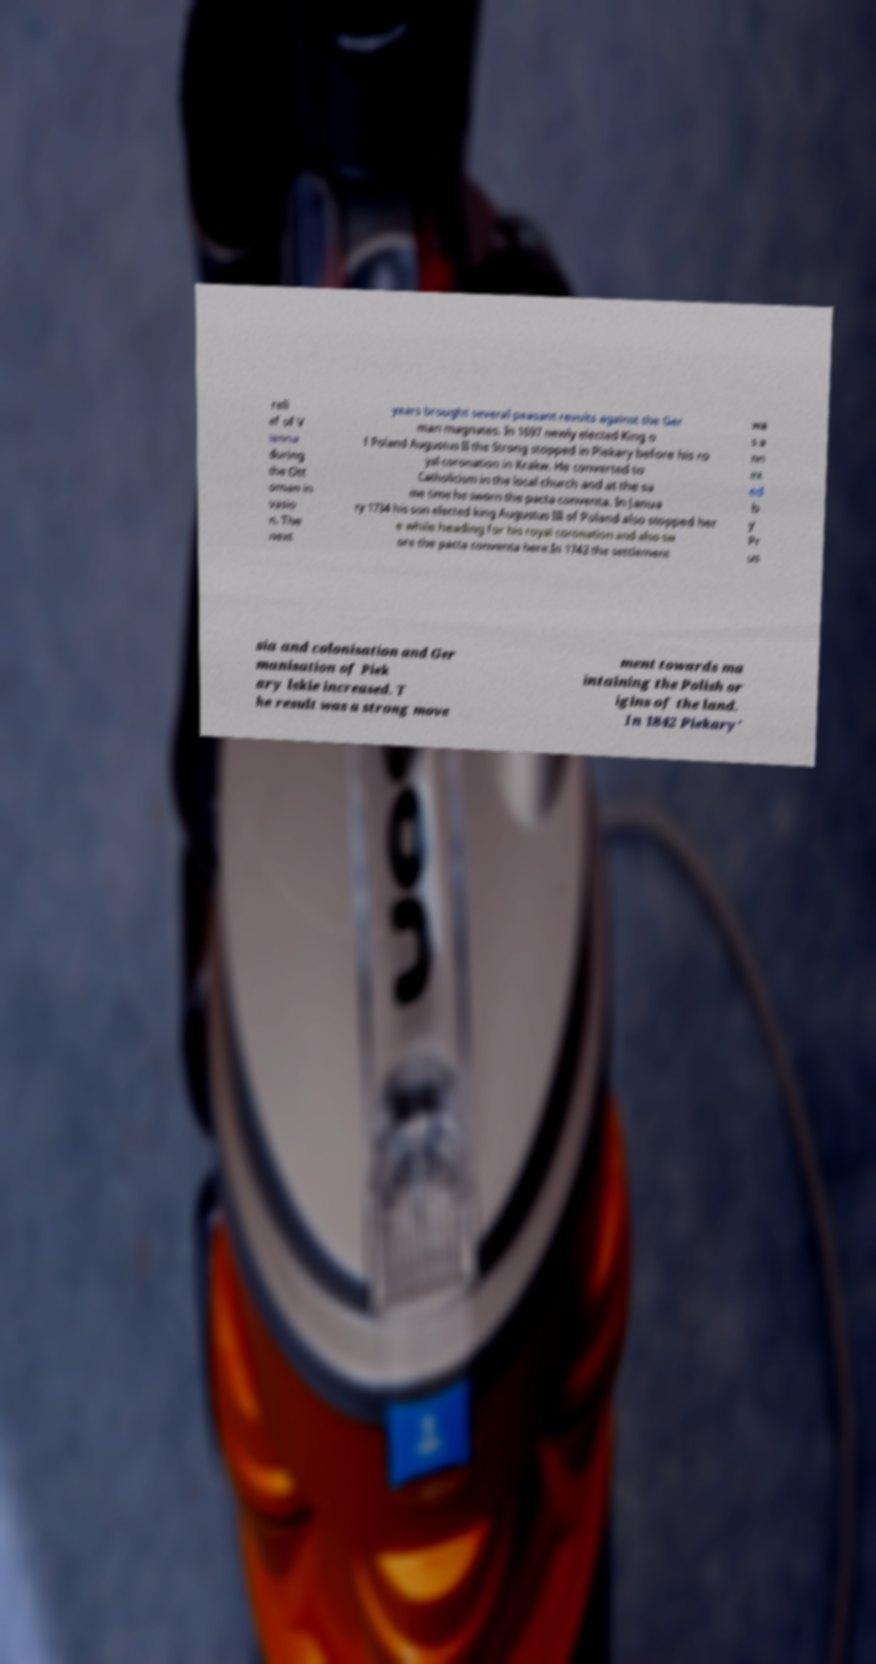Please read and relay the text visible in this image. What does it say? reli ef of V ienna during the Ott oman in vasio n. The next years brought several peasant revolts against the Ger man magnates. In 1697 newly elected King o f Poland Augustus II the Strong stopped in Piekary before his ro yal coronation in Krakw. He converted to Catholicism in the local church and at the sa me time he sworn the pacta conventa. In Janua ry 1734 his son elected king Augustus III of Poland also stopped her e while heading for his royal coronation and also sw ore the pacta conventa here.In 1742 the settlement wa s a nn ex ed b y Pr us sia and colonisation and Ger manisation of Piek ary lskie increased. T he result was a strong move ment towards ma intaining the Polish or igins of the land. In 1842 Piekary' 